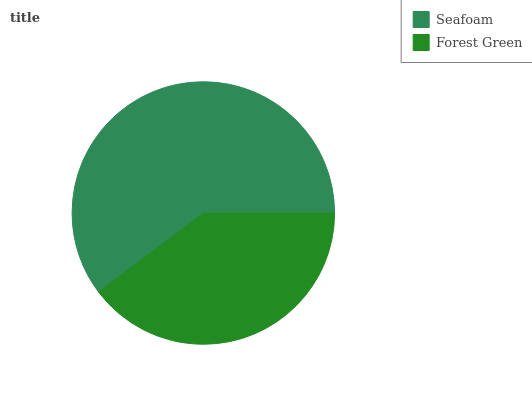Is Forest Green the minimum?
Answer yes or no. Yes. Is Seafoam the maximum?
Answer yes or no. Yes. Is Forest Green the maximum?
Answer yes or no. No. Is Seafoam greater than Forest Green?
Answer yes or no. Yes. Is Forest Green less than Seafoam?
Answer yes or no. Yes. Is Forest Green greater than Seafoam?
Answer yes or no. No. Is Seafoam less than Forest Green?
Answer yes or no. No. Is Seafoam the high median?
Answer yes or no. Yes. Is Forest Green the low median?
Answer yes or no. Yes. Is Forest Green the high median?
Answer yes or no. No. Is Seafoam the low median?
Answer yes or no. No. 